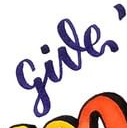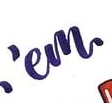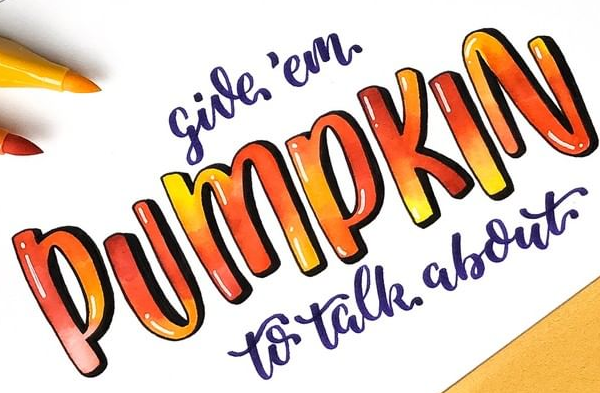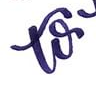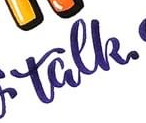Transcribe the words shown in these images in order, separated by a semicolon. give; 'em; PUMPKIN; to; talk 